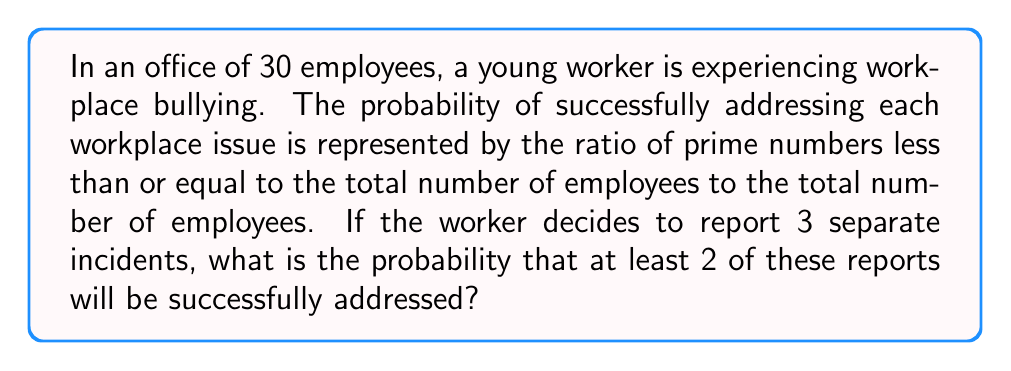Can you answer this question? Let's approach this step-by-step:

1) First, we need to find the prime numbers less than or equal to 30:
   2, 3, 5, 7, 11, 13, 17, 19, 23, 29
   There are 10 such prime numbers.

2) The probability of successfully addressing each issue is:
   $p = \frac{10}{30} = \frac{1}{3}$

3) Now, we need to calculate the probability of at least 2 out of 3 reports being successfully addressed. This is equivalent to the probability of either 2 or 3 reports being successful.

4) We can use the binomial probability formula for this:

   $P(X \geq 2) = P(X = 2) + P(X = 3)$

   Where $X$ is the number of successful reports.

5) The binomial probability formula is:

   $P(X = k) = \binom{n}{k} p^k (1-p)^{n-k}$

   Where $n$ is the number of trials (3 in this case), $k$ is the number of successes, $p$ is the probability of success on each trial.

6) Let's calculate:

   $P(X = 2) = \binom{3}{2} (\frac{1}{3})^2 (\frac{2}{3})^1 = 3 \cdot \frac{1}{9} \cdot \frac{2}{3} = \frac{2}{9}$

   $P(X = 3) = \binom{3}{3} (\frac{1}{3})^3 (\frac{2}{3})^0 = 1 \cdot \frac{1}{27} \cdot 1 = \frac{1}{27}$

7) Therefore, the probability of at least 2 successful reports is:

   $P(X \geq 2) = P(X = 2) + P(X = 3) = \frac{2}{9} + \frac{1}{27} = \frac{6}{27} + \frac{1}{27} = \frac{7}{27}$
Answer: The probability that at least 2 out of 3 reports will be successfully addressed is $\frac{7}{27}$ or approximately 0.2593 or 25.93%. 